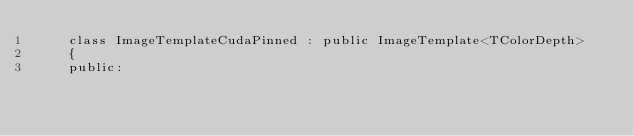<code> <loc_0><loc_0><loc_500><loc_500><_Cuda_>    class ImageTemplateCudaPinned : public ImageTemplate<TColorDepth>
    {
    public:</code> 